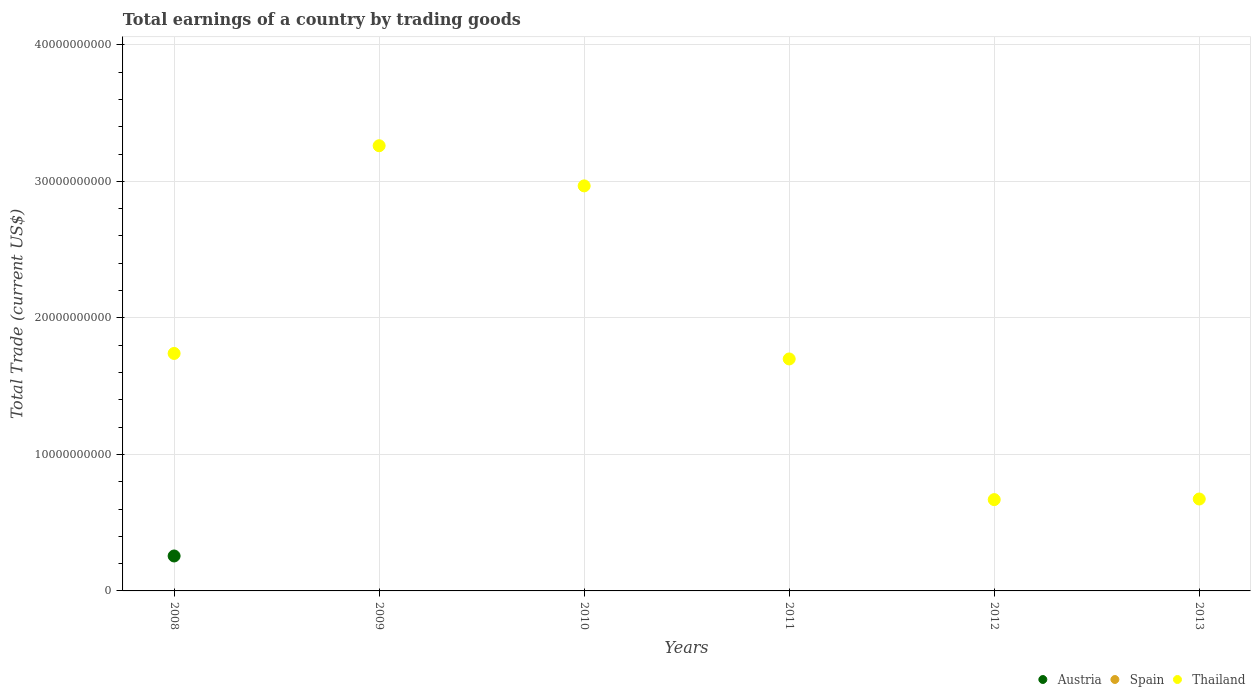How many different coloured dotlines are there?
Your answer should be compact. 2. Is the number of dotlines equal to the number of legend labels?
Provide a succinct answer. No. What is the total earnings in Thailand in 2008?
Ensure brevity in your answer.  1.74e+1. Across all years, what is the maximum total earnings in Austria?
Provide a short and direct response. 2.56e+09. Across all years, what is the minimum total earnings in Thailand?
Offer a very short reply. 6.69e+09. In which year was the total earnings in Austria maximum?
Give a very brief answer. 2008. What is the total total earnings in Austria in the graph?
Make the answer very short. 2.56e+09. What is the difference between the total earnings in Thailand in 2009 and that in 2011?
Offer a terse response. 1.56e+1. What is the difference between the total earnings in Thailand in 2013 and the total earnings in Austria in 2009?
Your answer should be compact. 6.73e+09. What is the average total earnings in Spain per year?
Give a very brief answer. 0. In the year 2008, what is the difference between the total earnings in Thailand and total earnings in Austria?
Provide a short and direct response. 1.48e+1. Is the total earnings in Thailand in 2009 less than that in 2011?
Keep it short and to the point. No. What is the difference between the highest and the second highest total earnings in Thailand?
Provide a succinct answer. 2.94e+09. What is the difference between the highest and the lowest total earnings in Austria?
Ensure brevity in your answer.  2.56e+09. In how many years, is the total earnings in Austria greater than the average total earnings in Austria taken over all years?
Your answer should be very brief. 1. Is the total earnings in Thailand strictly less than the total earnings in Austria over the years?
Your answer should be very brief. No. What is the difference between two consecutive major ticks on the Y-axis?
Provide a succinct answer. 1.00e+1. How are the legend labels stacked?
Ensure brevity in your answer.  Horizontal. What is the title of the graph?
Your answer should be very brief. Total earnings of a country by trading goods. What is the label or title of the X-axis?
Give a very brief answer. Years. What is the label or title of the Y-axis?
Your answer should be compact. Total Trade (current US$). What is the Total Trade (current US$) in Austria in 2008?
Your response must be concise. 2.56e+09. What is the Total Trade (current US$) of Spain in 2008?
Offer a terse response. 0. What is the Total Trade (current US$) in Thailand in 2008?
Your answer should be very brief. 1.74e+1. What is the Total Trade (current US$) in Austria in 2009?
Your response must be concise. 0. What is the Total Trade (current US$) of Thailand in 2009?
Ensure brevity in your answer.  3.26e+1. What is the Total Trade (current US$) of Spain in 2010?
Offer a very short reply. 0. What is the Total Trade (current US$) in Thailand in 2010?
Your answer should be compact. 2.97e+1. What is the Total Trade (current US$) of Thailand in 2011?
Offer a very short reply. 1.70e+1. What is the Total Trade (current US$) in Austria in 2012?
Make the answer very short. 0. What is the Total Trade (current US$) of Thailand in 2012?
Ensure brevity in your answer.  6.69e+09. What is the Total Trade (current US$) in Spain in 2013?
Keep it short and to the point. 0. What is the Total Trade (current US$) in Thailand in 2013?
Your response must be concise. 6.73e+09. Across all years, what is the maximum Total Trade (current US$) in Austria?
Make the answer very short. 2.56e+09. Across all years, what is the maximum Total Trade (current US$) of Thailand?
Offer a terse response. 3.26e+1. Across all years, what is the minimum Total Trade (current US$) in Thailand?
Your answer should be very brief. 6.69e+09. What is the total Total Trade (current US$) in Austria in the graph?
Your answer should be very brief. 2.56e+09. What is the total Total Trade (current US$) of Spain in the graph?
Provide a short and direct response. 0. What is the total Total Trade (current US$) of Thailand in the graph?
Ensure brevity in your answer.  1.10e+11. What is the difference between the Total Trade (current US$) of Thailand in 2008 and that in 2009?
Offer a terse response. -1.52e+1. What is the difference between the Total Trade (current US$) of Thailand in 2008 and that in 2010?
Your response must be concise. -1.23e+1. What is the difference between the Total Trade (current US$) of Thailand in 2008 and that in 2011?
Ensure brevity in your answer.  4.03e+08. What is the difference between the Total Trade (current US$) in Thailand in 2008 and that in 2012?
Make the answer very short. 1.07e+1. What is the difference between the Total Trade (current US$) of Thailand in 2008 and that in 2013?
Your response must be concise. 1.07e+1. What is the difference between the Total Trade (current US$) of Thailand in 2009 and that in 2010?
Keep it short and to the point. 2.94e+09. What is the difference between the Total Trade (current US$) of Thailand in 2009 and that in 2011?
Your answer should be very brief. 1.56e+1. What is the difference between the Total Trade (current US$) in Thailand in 2009 and that in 2012?
Offer a terse response. 2.59e+1. What is the difference between the Total Trade (current US$) of Thailand in 2009 and that in 2013?
Provide a short and direct response. 2.59e+1. What is the difference between the Total Trade (current US$) of Thailand in 2010 and that in 2011?
Keep it short and to the point. 1.27e+1. What is the difference between the Total Trade (current US$) in Thailand in 2010 and that in 2012?
Make the answer very short. 2.30e+1. What is the difference between the Total Trade (current US$) in Thailand in 2010 and that in 2013?
Give a very brief answer. 2.29e+1. What is the difference between the Total Trade (current US$) of Thailand in 2011 and that in 2012?
Provide a short and direct response. 1.03e+1. What is the difference between the Total Trade (current US$) of Thailand in 2011 and that in 2013?
Provide a succinct answer. 1.03e+1. What is the difference between the Total Trade (current US$) of Thailand in 2012 and that in 2013?
Your response must be concise. -4.36e+07. What is the difference between the Total Trade (current US$) of Austria in 2008 and the Total Trade (current US$) of Thailand in 2009?
Your answer should be compact. -3.00e+1. What is the difference between the Total Trade (current US$) of Austria in 2008 and the Total Trade (current US$) of Thailand in 2010?
Provide a short and direct response. -2.71e+1. What is the difference between the Total Trade (current US$) of Austria in 2008 and the Total Trade (current US$) of Thailand in 2011?
Your answer should be compact. -1.44e+1. What is the difference between the Total Trade (current US$) in Austria in 2008 and the Total Trade (current US$) in Thailand in 2012?
Your response must be concise. -4.13e+09. What is the difference between the Total Trade (current US$) in Austria in 2008 and the Total Trade (current US$) in Thailand in 2013?
Keep it short and to the point. -4.17e+09. What is the average Total Trade (current US$) of Austria per year?
Your answer should be very brief. 4.27e+08. What is the average Total Trade (current US$) of Spain per year?
Your answer should be compact. 0. What is the average Total Trade (current US$) of Thailand per year?
Give a very brief answer. 1.83e+1. In the year 2008, what is the difference between the Total Trade (current US$) in Austria and Total Trade (current US$) in Thailand?
Keep it short and to the point. -1.48e+1. What is the ratio of the Total Trade (current US$) in Thailand in 2008 to that in 2009?
Make the answer very short. 0.53. What is the ratio of the Total Trade (current US$) in Thailand in 2008 to that in 2010?
Offer a terse response. 0.59. What is the ratio of the Total Trade (current US$) of Thailand in 2008 to that in 2011?
Give a very brief answer. 1.02. What is the ratio of the Total Trade (current US$) in Thailand in 2008 to that in 2012?
Offer a very short reply. 2.6. What is the ratio of the Total Trade (current US$) in Thailand in 2008 to that in 2013?
Your answer should be very brief. 2.58. What is the ratio of the Total Trade (current US$) in Thailand in 2009 to that in 2010?
Make the answer very short. 1.1. What is the ratio of the Total Trade (current US$) in Thailand in 2009 to that in 2011?
Provide a succinct answer. 1.92. What is the ratio of the Total Trade (current US$) in Thailand in 2009 to that in 2012?
Your response must be concise. 4.88. What is the ratio of the Total Trade (current US$) of Thailand in 2009 to that in 2013?
Provide a short and direct response. 4.84. What is the ratio of the Total Trade (current US$) of Thailand in 2010 to that in 2011?
Ensure brevity in your answer.  1.75. What is the ratio of the Total Trade (current US$) in Thailand in 2010 to that in 2012?
Provide a succinct answer. 4.44. What is the ratio of the Total Trade (current US$) of Thailand in 2010 to that in 2013?
Provide a succinct answer. 4.41. What is the ratio of the Total Trade (current US$) in Thailand in 2011 to that in 2012?
Your response must be concise. 2.54. What is the ratio of the Total Trade (current US$) of Thailand in 2011 to that in 2013?
Make the answer very short. 2.52. What is the ratio of the Total Trade (current US$) in Thailand in 2012 to that in 2013?
Your response must be concise. 0.99. What is the difference between the highest and the second highest Total Trade (current US$) of Thailand?
Give a very brief answer. 2.94e+09. What is the difference between the highest and the lowest Total Trade (current US$) of Austria?
Keep it short and to the point. 2.56e+09. What is the difference between the highest and the lowest Total Trade (current US$) of Thailand?
Ensure brevity in your answer.  2.59e+1. 